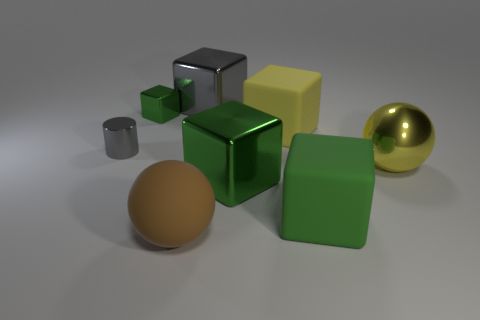Are the brown sphere and the green block right of the large yellow rubber thing made of the same material?
Your response must be concise. Yes. How many objects are tiny gray blocks or big brown objects?
Provide a short and direct response. 1. There is a green shiny cube behind the tiny gray metallic object; does it have the same size as the gray thing on the left side of the gray metallic block?
Your response must be concise. Yes. What number of spheres are brown matte objects or green matte objects?
Your response must be concise. 1. Are any small red metal objects visible?
Give a very brief answer. No. Are there any other things that are the same shape as the tiny gray object?
Your response must be concise. No. Does the big matte sphere have the same color as the large shiny ball?
Give a very brief answer. No. How many things are either gray metal things that are behind the tiny gray cylinder or small gray things?
Make the answer very short. 2. How many metallic cylinders are right of the gray shiny object that is in front of the gray metallic object behind the small metallic block?
Ensure brevity in your answer.  0. The gray metallic object on the left side of the rubber thing to the left of the large block that is behind the small cube is what shape?
Provide a succinct answer. Cylinder. 